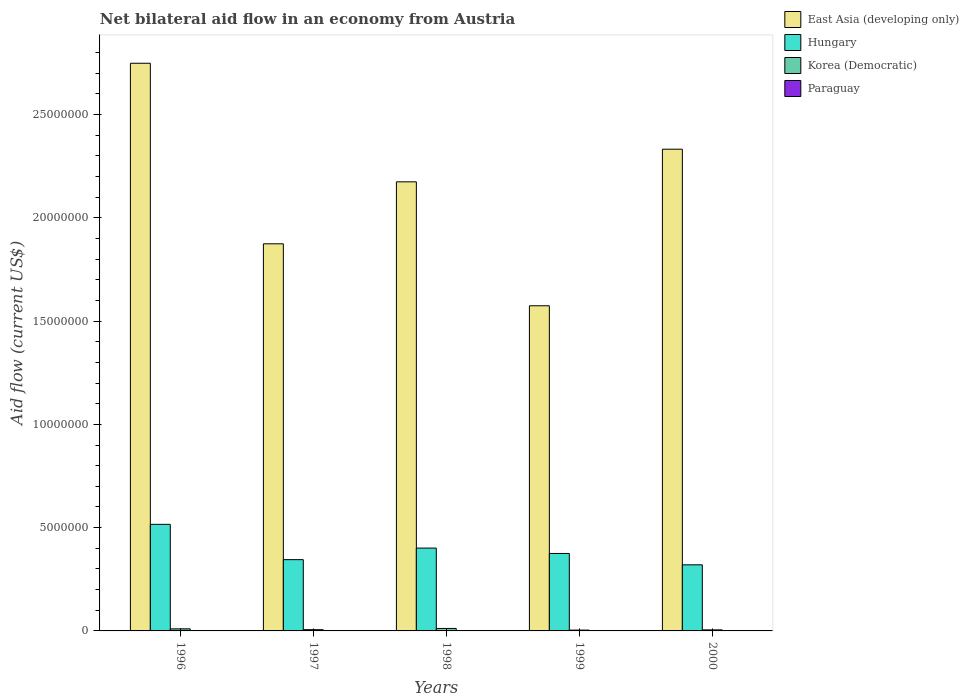How many different coloured bars are there?
Your response must be concise. 4. How many bars are there on the 3rd tick from the left?
Provide a succinct answer. 4. What is the label of the 2nd group of bars from the left?
Provide a succinct answer. 1997. What is the net bilateral aid flow in East Asia (developing only) in 1996?
Give a very brief answer. 2.75e+07. Across all years, what is the maximum net bilateral aid flow in East Asia (developing only)?
Your answer should be compact. 2.75e+07. Across all years, what is the minimum net bilateral aid flow in Hungary?
Provide a short and direct response. 3.20e+06. What is the total net bilateral aid flow in Korea (Democratic) in the graph?
Provide a succinct answer. 3.70e+05. What is the difference between the net bilateral aid flow in Hungary in 1999 and that in 2000?
Offer a very short reply. 5.50e+05. What is the difference between the net bilateral aid flow in East Asia (developing only) in 1998 and the net bilateral aid flow in Korea (Democratic) in 1997?
Your answer should be very brief. 2.17e+07. What is the average net bilateral aid flow in East Asia (developing only) per year?
Provide a short and direct response. 2.14e+07. In the year 1998, what is the difference between the net bilateral aid flow in Korea (Democratic) and net bilateral aid flow in Hungary?
Ensure brevity in your answer.  -3.89e+06. In how many years, is the net bilateral aid flow in East Asia (developing only) greater than 4000000 US$?
Make the answer very short. 5. Is the net bilateral aid flow in Korea (Democratic) in 1996 less than that in 1998?
Offer a very short reply. Yes. What is the difference between the highest and the second highest net bilateral aid flow in Hungary?
Your answer should be very brief. 1.15e+06. What does the 1st bar from the left in 1996 represents?
Ensure brevity in your answer.  East Asia (developing only). What does the 3rd bar from the right in 1997 represents?
Keep it short and to the point. Hungary. How many bars are there?
Give a very brief answer. 20. Are the values on the major ticks of Y-axis written in scientific E-notation?
Your answer should be compact. No. Does the graph contain any zero values?
Keep it short and to the point. No. Where does the legend appear in the graph?
Your answer should be compact. Top right. How many legend labels are there?
Ensure brevity in your answer.  4. What is the title of the graph?
Offer a terse response. Net bilateral aid flow in an economy from Austria. What is the label or title of the Y-axis?
Keep it short and to the point. Aid flow (current US$). What is the Aid flow (current US$) in East Asia (developing only) in 1996?
Your response must be concise. 2.75e+07. What is the Aid flow (current US$) of Hungary in 1996?
Give a very brief answer. 5.16e+06. What is the Aid flow (current US$) of East Asia (developing only) in 1997?
Make the answer very short. 1.87e+07. What is the Aid flow (current US$) of Hungary in 1997?
Provide a short and direct response. 3.45e+06. What is the Aid flow (current US$) of Korea (Democratic) in 1997?
Ensure brevity in your answer.  6.00e+04. What is the Aid flow (current US$) of East Asia (developing only) in 1998?
Provide a short and direct response. 2.17e+07. What is the Aid flow (current US$) of Hungary in 1998?
Provide a succinct answer. 4.01e+06. What is the Aid flow (current US$) in Korea (Democratic) in 1998?
Give a very brief answer. 1.20e+05. What is the Aid flow (current US$) in East Asia (developing only) in 1999?
Provide a succinct answer. 1.57e+07. What is the Aid flow (current US$) in Hungary in 1999?
Ensure brevity in your answer.  3.75e+06. What is the Aid flow (current US$) in Paraguay in 1999?
Ensure brevity in your answer.  2.00e+04. What is the Aid flow (current US$) in East Asia (developing only) in 2000?
Give a very brief answer. 2.33e+07. What is the Aid flow (current US$) in Hungary in 2000?
Offer a terse response. 3.20e+06. Across all years, what is the maximum Aid flow (current US$) of East Asia (developing only)?
Offer a terse response. 2.75e+07. Across all years, what is the maximum Aid flow (current US$) of Hungary?
Keep it short and to the point. 5.16e+06. Across all years, what is the minimum Aid flow (current US$) in East Asia (developing only)?
Provide a succinct answer. 1.57e+07. Across all years, what is the minimum Aid flow (current US$) of Hungary?
Offer a terse response. 3.20e+06. What is the total Aid flow (current US$) in East Asia (developing only) in the graph?
Your response must be concise. 1.07e+08. What is the total Aid flow (current US$) in Hungary in the graph?
Offer a terse response. 1.96e+07. What is the difference between the Aid flow (current US$) in East Asia (developing only) in 1996 and that in 1997?
Your answer should be compact. 8.74e+06. What is the difference between the Aid flow (current US$) in Hungary in 1996 and that in 1997?
Ensure brevity in your answer.  1.71e+06. What is the difference between the Aid flow (current US$) in Korea (Democratic) in 1996 and that in 1997?
Provide a short and direct response. 4.00e+04. What is the difference between the Aid flow (current US$) of Paraguay in 1996 and that in 1997?
Provide a succinct answer. 10000. What is the difference between the Aid flow (current US$) of East Asia (developing only) in 1996 and that in 1998?
Provide a succinct answer. 5.74e+06. What is the difference between the Aid flow (current US$) of Hungary in 1996 and that in 1998?
Provide a short and direct response. 1.15e+06. What is the difference between the Aid flow (current US$) in East Asia (developing only) in 1996 and that in 1999?
Ensure brevity in your answer.  1.17e+07. What is the difference between the Aid flow (current US$) of Hungary in 1996 and that in 1999?
Your response must be concise. 1.41e+06. What is the difference between the Aid flow (current US$) in Korea (Democratic) in 1996 and that in 1999?
Provide a short and direct response. 6.00e+04. What is the difference between the Aid flow (current US$) of Paraguay in 1996 and that in 1999?
Provide a short and direct response. 0. What is the difference between the Aid flow (current US$) in East Asia (developing only) in 1996 and that in 2000?
Provide a succinct answer. 4.16e+06. What is the difference between the Aid flow (current US$) of Hungary in 1996 and that in 2000?
Ensure brevity in your answer.  1.96e+06. What is the difference between the Aid flow (current US$) of Korea (Democratic) in 1996 and that in 2000?
Offer a terse response. 5.00e+04. What is the difference between the Aid flow (current US$) of Hungary in 1997 and that in 1998?
Provide a short and direct response. -5.60e+05. What is the difference between the Aid flow (current US$) of Korea (Democratic) in 1997 and that in 1998?
Keep it short and to the point. -6.00e+04. What is the difference between the Aid flow (current US$) in Paraguay in 1997 and that in 1998?
Keep it short and to the point. 0. What is the difference between the Aid flow (current US$) in Korea (Democratic) in 1997 and that in 1999?
Your response must be concise. 2.00e+04. What is the difference between the Aid flow (current US$) of East Asia (developing only) in 1997 and that in 2000?
Provide a succinct answer. -4.58e+06. What is the difference between the Aid flow (current US$) in Hungary in 1997 and that in 2000?
Your response must be concise. 2.50e+05. What is the difference between the Aid flow (current US$) of Korea (Democratic) in 1997 and that in 2000?
Give a very brief answer. 10000. What is the difference between the Aid flow (current US$) in Hungary in 1998 and that in 1999?
Keep it short and to the point. 2.60e+05. What is the difference between the Aid flow (current US$) in Korea (Democratic) in 1998 and that in 1999?
Offer a very short reply. 8.00e+04. What is the difference between the Aid flow (current US$) of Paraguay in 1998 and that in 1999?
Keep it short and to the point. -10000. What is the difference between the Aid flow (current US$) in East Asia (developing only) in 1998 and that in 2000?
Offer a terse response. -1.58e+06. What is the difference between the Aid flow (current US$) of Hungary in 1998 and that in 2000?
Your answer should be compact. 8.10e+05. What is the difference between the Aid flow (current US$) of East Asia (developing only) in 1999 and that in 2000?
Give a very brief answer. -7.58e+06. What is the difference between the Aid flow (current US$) of Paraguay in 1999 and that in 2000?
Offer a very short reply. 10000. What is the difference between the Aid flow (current US$) of East Asia (developing only) in 1996 and the Aid flow (current US$) of Hungary in 1997?
Provide a succinct answer. 2.40e+07. What is the difference between the Aid flow (current US$) of East Asia (developing only) in 1996 and the Aid flow (current US$) of Korea (Democratic) in 1997?
Provide a succinct answer. 2.74e+07. What is the difference between the Aid flow (current US$) in East Asia (developing only) in 1996 and the Aid flow (current US$) in Paraguay in 1997?
Offer a terse response. 2.75e+07. What is the difference between the Aid flow (current US$) of Hungary in 1996 and the Aid flow (current US$) of Korea (Democratic) in 1997?
Make the answer very short. 5.10e+06. What is the difference between the Aid flow (current US$) of Hungary in 1996 and the Aid flow (current US$) of Paraguay in 1997?
Your response must be concise. 5.15e+06. What is the difference between the Aid flow (current US$) of Korea (Democratic) in 1996 and the Aid flow (current US$) of Paraguay in 1997?
Offer a very short reply. 9.00e+04. What is the difference between the Aid flow (current US$) of East Asia (developing only) in 1996 and the Aid flow (current US$) of Hungary in 1998?
Ensure brevity in your answer.  2.35e+07. What is the difference between the Aid flow (current US$) in East Asia (developing only) in 1996 and the Aid flow (current US$) in Korea (Democratic) in 1998?
Ensure brevity in your answer.  2.74e+07. What is the difference between the Aid flow (current US$) of East Asia (developing only) in 1996 and the Aid flow (current US$) of Paraguay in 1998?
Make the answer very short. 2.75e+07. What is the difference between the Aid flow (current US$) in Hungary in 1996 and the Aid flow (current US$) in Korea (Democratic) in 1998?
Your answer should be compact. 5.04e+06. What is the difference between the Aid flow (current US$) in Hungary in 1996 and the Aid flow (current US$) in Paraguay in 1998?
Your answer should be compact. 5.15e+06. What is the difference between the Aid flow (current US$) in Korea (Democratic) in 1996 and the Aid flow (current US$) in Paraguay in 1998?
Your answer should be very brief. 9.00e+04. What is the difference between the Aid flow (current US$) of East Asia (developing only) in 1996 and the Aid flow (current US$) of Hungary in 1999?
Your answer should be compact. 2.37e+07. What is the difference between the Aid flow (current US$) of East Asia (developing only) in 1996 and the Aid flow (current US$) of Korea (Democratic) in 1999?
Ensure brevity in your answer.  2.74e+07. What is the difference between the Aid flow (current US$) of East Asia (developing only) in 1996 and the Aid flow (current US$) of Paraguay in 1999?
Provide a short and direct response. 2.75e+07. What is the difference between the Aid flow (current US$) in Hungary in 1996 and the Aid flow (current US$) in Korea (Democratic) in 1999?
Keep it short and to the point. 5.12e+06. What is the difference between the Aid flow (current US$) in Hungary in 1996 and the Aid flow (current US$) in Paraguay in 1999?
Provide a succinct answer. 5.14e+06. What is the difference between the Aid flow (current US$) of East Asia (developing only) in 1996 and the Aid flow (current US$) of Hungary in 2000?
Offer a terse response. 2.43e+07. What is the difference between the Aid flow (current US$) of East Asia (developing only) in 1996 and the Aid flow (current US$) of Korea (Democratic) in 2000?
Make the answer very short. 2.74e+07. What is the difference between the Aid flow (current US$) of East Asia (developing only) in 1996 and the Aid flow (current US$) of Paraguay in 2000?
Give a very brief answer. 2.75e+07. What is the difference between the Aid flow (current US$) of Hungary in 1996 and the Aid flow (current US$) of Korea (Democratic) in 2000?
Keep it short and to the point. 5.11e+06. What is the difference between the Aid flow (current US$) in Hungary in 1996 and the Aid flow (current US$) in Paraguay in 2000?
Offer a terse response. 5.15e+06. What is the difference between the Aid flow (current US$) of Korea (Democratic) in 1996 and the Aid flow (current US$) of Paraguay in 2000?
Offer a very short reply. 9.00e+04. What is the difference between the Aid flow (current US$) of East Asia (developing only) in 1997 and the Aid flow (current US$) of Hungary in 1998?
Give a very brief answer. 1.47e+07. What is the difference between the Aid flow (current US$) of East Asia (developing only) in 1997 and the Aid flow (current US$) of Korea (Democratic) in 1998?
Give a very brief answer. 1.86e+07. What is the difference between the Aid flow (current US$) of East Asia (developing only) in 1997 and the Aid flow (current US$) of Paraguay in 1998?
Your response must be concise. 1.87e+07. What is the difference between the Aid flow (current US$) in Hungary in 1997 and the Aid flow (current US$) in Korea (Democratic) in 1998?
Make the answer very short. 3.33e+06. What is the difference between the Aid flow (current US$) in Hungary in 1997 and the Aid flow (current US$) in Paraguay in 1998?
Provide a succinct answer. 3.44e+06. What is the difference between the Aid flow (current US$) in East Asia (developing only) in 1997 and the Aid flow (current US$) in Hungary in 1999?
Keep it short and to the point. 1.50e+07. What is the difference between the Aid flow (current US$) of East Asia (developing only) in 1997 and the Aid flow (current US$) of Korea (Democratic) in 1999?
Give a very brief answer. 1.87e+07. What is the difference between the Aid flow (current US$) in East Asia (developing only) in 1997 and the Aid flow (current US$) in Paraguay in 1999?
Make the answer very short. 1.87e+07. What is the difference between the Aid flow (current US$) of Hungary in 1997 and the Aid flow (current US$) of Korea (Democratic) in 1999?
Your answer should be very brief. 3.41e+06. What is the difference between the Aid flow (current US$) of Hungary in 1997 and the Aid flow (current US$) of Paraguay in 1999?
Make the answer very short. 3.43e+06. What is the difference between the Aid flow (current US$) in East Asia (developing only) in 1997 and the Aid flow (current US$) in Hungary in 2000?
Provide a succinct answer. 1.55e+07. What is the difference between the Aid flow (current US$) in East Asia (developing only) in 1997 and the Aid flow (current US$) in Korea (Democratic) in 2000?
Provide a short and direct response. 1.87e+07. What is the difference between the Aid flow (current US$) of East Asia (developing only) in 1997 and the Aid flow (current US$) of Paraguay in 2000?
Offer a very short reply. 1.87e+07. What is the difference between the Aid flow (current US$) in Hungary in 1997 and the Aid flow (current US$) in Korea (Democratic) in 2000?
Provide a succinct answer. 3.40e+06. What is the difference between the Aid flow (current US$) in Hungary in 1997 and the Aid flow (current US$) in Paraguay in 2000?
Provide a succinct answer. 3.44e+06. What is the difference between the Aid flow (current US$) in East Asia (developing only) in 1998 and the Aid flow (current US$) in Hungary in 1999?
Provide a short and direct response. 1.80e+07. What is the difference between the Aid flow (current US$) of East Asia (developing only) in 1998 and the Aid flow (current US$) of Korea (Democratic) in 1999?
Your answer should be very brief. 2.17e+07. What is the difference between the Aid flow (current US$) in East Asia (developing only) in 1998 and the Aid flow (current US$) in Paraguay in 1999?
Provide a short and direct response. 2.17e+07. What is the difference between the Aid flow (current US$) in Hungary in 1998 and the Aid flow (current US$) in Korea (Democratic) in 1999?
Your answer should be compact. 3.97e+06. What is the difference between the Aid flow (current US$) of Hungary in 1998 and the Aid flow (current US$) of Paraguay in 1999?
Your response must be concise. 3.99e+06. What is the difference between the Aid flow (current US$) in Korea (Democratic) in 1998 and the Aid flow (current US$) in Paraguay in 1999?
Provide a short and direct response. 1.00e+05. What is the difference between the Aid flow (current US$) of East Asia (developing only) in 1998 and the Aid flow (current US$) of Hungary in 2000?
Your response must be concise. 1.85e+07. What is the difference between the Aid flow (current US$) in East Asia (developing only) in 1998 and the Aid flow (current US$) in Korea (Democratic) in 2000?
Your answer should be compact. 2.17e+07. What is the difference between the Aid flow (current US$) of East Asia (developing only) in 1998 and the Aid flow (current US$) of Paraguay in 2000?
Provide a short and direct response. 2.17e+07. What is the difference between the Aid flow (current US$) of Hungary in 1998 and the Aid flow (current US$) of Korea (Democratic) in 2000?
Provide a succinct answer. 3.96e+06. What is the difference between the Aid flow (current US$) in East Asia (developing only) in 1999 and the Aid flow (current US$) in Hungary in 2000?
Your answer should be compact. 1.25e+07. What is the difference between the Aid flow (current US$) of East Asia (developing only) in 1999 and the Aid flow (current US$) of Korea (Democratic) in 2000?
Offer a terse response. 1.57e+07. What is the difference between the Aid flow (current US$) in East Asia (developing only) in 1999 and the Aid flow (current US$) in Paraguay in 2000?
Keep it short and to the point. 1.57e+07. What is the difference between the Aid flow (current US$) of Hungary in 1999 and the Aid flow (current US$) of Korea (Democratic) in 2000?
Your answer should be compact. 3.70e+06. What is the difference between the Aid flow (current US$) of Hungary in 1999 and the Aid flow (current US$) of Paraguay in 2000?
Your answer should be very brief. 3.74e+06. What is the difference between the Aid flow (current US$) of Korea (Democratic) in 1999 and the Aid flow (current US$) of Paraguay in 2000?
Give a very brief answer. 3.00e+04. What is the average Aid flow (current US$) in East Asia (developing only) per year?
Provide a succinct answer. 2.14e+07. What is the average Aid flow (current US$) of Hungary per year?
Offer a very short reply. 3.91e+06. What is the average Aid flow (current US$) in Korea (Democratic) per year?
Your answer should be compact. 7.40e+04. What is the average Aid flow (current US$) in Paraguay per year?
Your answer should be compact. 1.40e+04. In the year 1996, what is the difference between the Aid flow (current US$) in East Asia (developing only) and Aid flow (current US$) in Hungary?
Keep it short and to the point. 2.23e+07. In the year 1996, what is the difference between the Aid flow (current US$) of East Asia (developing only) and Aid flow (current US$) of Korea (Democratic)?
Ensure brevity in your answer.  2.74e+07. In the year 1996, what is the difference between the Aid flow (current US$) in East Asia (developing only) and Aid flow (current US$) in Paraguay?
Your answer should be very brief. 2.75e+07. In the year 1996, what is the difference between the Aid flow (current US$) of Hungary and Aid flow (current US$) of Korea (Democratic)?
Offer a terse response. 5.06e+06. In the year 1996, what is the difference between the Aid flow (current US$) in Hungary and Aid flow (current US$) in Paraguay?
Your answer should be very brief. 5.14e+06. In the year 1997, what is the difference between the Aid flow (current US$) of East Asia (developing only) and Aid flow (current US$) of Hungary?
Offer a very short reply. 1.53e+07. In the year 1997, what is the difference between the Aid flow (current US$) of East Asia (developing only) and Aid flow (current US$) of Korea (Democratic)?
Your answer should be very brief. 1.87e+07. In the year 1997, what is the difference between the Aid flow (current US$) of East Asia (developing only) and Aid flow (current US$) of Paraguay?
Your response must be concise. 1.87e+07. In the year 1997, what is the difference between the Aid flow (current US$) of Hungary and Aid flow (current US$) of Korea (Democratic)?
Your response must be concise. 3.39e+06. In the year 1997, what is the difference between the Aid flow (current US$) of Hungary and Aid flow (current US$) of Paraguay?
Your response must be concise. 3.44e+06. In the year 1997, what is the difference between the Aid flow (current US$) of Korea (Democratic) and Aid flow (current US$) of Paraguay?
Provide a succinct answer. 5.00e+04. In the year 1998, what is the difference between the Aid flow (current US$) of East Asia (developing only) and Aid flow (current US$) of Hungary?
Provide a short and direct response. 1.77e+07. In the year 1998, what is the difference between the Aid flow (current US$) of East Asia (developing only) and Aid flow (current US$) of Korea (Democratic)?
Ensure brevity in your answer.  2.16e+07. In the year 1998, what is the difference between the Aid flow (current US$) of East Asia (developing only) and Aid flow (current US$) of Paraguay?
Ensure brevity in your answer.  2.17e+07. In the year 1998, what is the difference between the Aid flow (current US$) of Hungary and Aid flow (current US$) of Korea (Democratic)?
Offer a very short reply. 3.89e+06. In the year 1998, what is the difference between the Aid flow (current US$) in Hungary and Aid flow (current US$) in Paraguay?
Your answer should be compact. 4.00e+06. In the year 1999, what is the difference between the Aid flow (current US$) in East Asia (developing only) and Aid flow (current US$) in Hungary?
Your response must be concise. 1.20e+07. In the year 1999, what is the difference between the Aid flow (current US$) in East Asia (developing only) and Aid flow (current US$) in Korea (Democratic)?
Your answer should be very brief. 1.57e+07. In the year 1999, what is the difference between the Aid flow (current US$) of East Asia (developing only) and Aid flow (current US$) of Paraguay?
Make the answer very short. 1.57e+07. In the year 1999, what is the difference between the Aid flow (current US$) of Hungary and Aid flow (current US$) of Korea (Democratic)?
Your response must be concise. 3.71e+06. In the year 1999, what is the difference between the Aid flow (current US$) of Hungary and Aid flow (current US$) of Paraguay?
Your answer should be very brief. 3.73e+06. In the year 1999, what is the difference between the Aid flow (current US$) of Korea (Democratic) and Aid flow (current US$) of Paraguay?
Your response must be concise. 2.00e+04. In the year 2000, what is the difference between the Aid flow (current US$) in East Asia (developing only) and Aid flow (current US$) in Hungary?
Provide a short and direct response. 2.01e+07. In the year 2000, what is the difference between the Aid flow (current US$) in East Asia (developing only) and Aid flow (current US$) in Korea (Democratic)?
Offer a terse response. 2.33e+07. In the year 2000, what is the difference between the Aid flow (current US$) in East Asia (developing only) and Aid flow (current US$) in Paraguay?
Give a very brief answer. 2.33e+07. In the year 2000, what is the difference between the Aid flow (current US$) of Hungary and Aid flow (current US$) of Korea (Democratic)?
Offer a terse response. 3.15e+06. In the year 2000, what is the difference between the Aid flow (current US$) of Hungary and Aid flow (current US$) of Paraguay?
Ensure brevity in your answer.  3.19e+06. In the year 2000, what is the difference between the Aid flow (current US$) of Korea (Democratic) and Aid flow (current US$) of Paraguay?
Keep it short and to the point. 4.00e+04. What is the ratio of the Aid flow (current US$) of East Asia (developing only) in 1996 to that in 1997?
Ensure brevity in your answer.  1.47. What is the ratio of the Aid flow (current US$) of Hungary in 1996 to that in 1997?
Offer a terse response. 1.5. What is the ratio of the Aid flow (current US$) in Korea (Democratic) in 1996 to that in 1997?
Ensure brevity in your answer.  1.67. What is the ratio of the Aid flow (current US$) in Paraguay in 1996 to that in 1997?
Your answer should be compact. 2. What is the ratio of the Aid flow (current US$) in East Asia (developing only) in 1996 to that in 1998?
Provide a short and direct response. 1.26. What is the ratio of the Aid flow (current US$) in Hungary in 1996 to that in 1998?
Ensure brevity in your answer.  1.29. What is the ratio of the Aid flow (current US$) of Korea (Democratic) in 1996 to that in 1998?
Give a very brief answer. 0.83. What is the ratio of the Aid flow (current US$) of Paraguay in 1996 to that in 1998?
Your response must be concise. 2. What is the ratio of the Aid flow (current US$) of East Asia (developing only) in 1996 to that in 1999?
Make the answer very short. 1.75. What is the ratio of the Aid flow (current US$) in Hungary in 1996 to that in 1999?
Keep it short and to the point. 1.38. What is the ratio of the Aid flow (current US$) of Paraguay in 1996 to that in 1999?
Give a very brief answer. 1. What is the ratio of the Aid flow (current US$) in East Asia (developing only) in 1996 to that in 2000?
Make the answer very short. 1.18. What is the ratio of the Aid flow (current US$) of Hungary in 1996 to that in 2000?
Your answer should be very brief. 1.61. What is the ratio of the Aid flow (current US$) of Paraguay in 1996 to that in 2000?
Give a very brief answer. 2. What is the ratio of the Aid flow (current US$) in East Asia (developing only) in 1997 to that in 1998?
Offer a very short reply. 0.86. What is the ratio of the Aid flow (current US$) in Hungary in 1997 to that in 1998?
Offer a very short reply. 0.86. What is the ratio of the Aid flow (current US$) of Korea (Democratic) in 1997 to that in 1998?
Offer a very short reply. 0.5. What is the ratio of the Aid flow (current US$) of Paraguay in 1997 to that in 1998?
Ensure brevity in your answer.  1. What is the ratio of the Aid flow (current US$) of East Asia (developing only) in 1997 to that in 1999?
Your response must be concise. 1.19. What is the ratio of the Aid flow (current US$) of Korea (Democratic) in 1997 to that in 1999?
Your response must be concise. 1.5. What is the ratio of the Aid flow (current US$) in East Asia (developing only) in 1997 to that in 2000?
Offer a terse response. 0.8. What is the ratio of the Aid flow (current US$) in Hungary in 1997 to that in 2000?
Provide a short and direct response. 1.08. What is the ratio of the Aid flow (current US$) in Korea (Democratic) in 1997 to that in 2000?
Your answer should be compact. 1.2. What is the ratio of the Aid flow (current US$) of East Asia (developing only) in 1998 to that in 1999?
Your answer should be very brief. 1.38. What is the ratio of the Aid flow (current US$) in Hungary in 1998 to that in 1999?
Your answer should be compact. 1.07. What is the ratio of the Aid flow (current US$) in Korea (Democratic) in 1998 to that in 1999?
Your answer should be compact. 3. What is the ratio of the Aid flow (current US$) in East Asia (developing only) in 1998 to that in 2000?
Ensure brevity in your answer.  0.93. What is the ratio of the Aid flow (current US$) of Hungary in 1998 to that in 2000?
Offer a very short reply. 1.25. What is the ratio of the Aid flow (current US$) of Korea (Democratic) in 1998 to that in 2000?
Give a very brief answer. 2.4. What is the ratio of the Aid flow (current US$) in Paraguay in 1998 to that in 2000?
Provide a short and direct response. 1. What is the ratio of the Aid flow (current US$) in East Asia (developing only) in 1999 to that in 2000?
Provide a short and direct response. 0.68. What is the ratio of the Aid flow (current US$) of Hungary in 1999 to that in 2000?
Offer a terse response. 1.17. What is the difference between the highest and the second highest Aid flow (current US$) in East Asia (developing only)?
Offer a very short reply. 4.16e+06. What is the difference between the highest and the second highest Aid flow (current US$) of Hungary?
Offer a very short reply. 1.15e+06. What is the difference between the highest and the second highest Aid flow (current US$) of Paraguay?
Your response must be concise. 0. What is the difference between the highest and the lowest Aid flow (current US$) of East Asia (developing only)?
Provide a succinct answer. 1.17e+07. What is the difference between the highest and the lowest Aid flow (current US$) of Hungary?
Offer a very short reply. 1.96e+06. What is the difference between the highest and the lowest Aid flow (current US$) in Paraguay?
Your answer should be compact. 10000. 